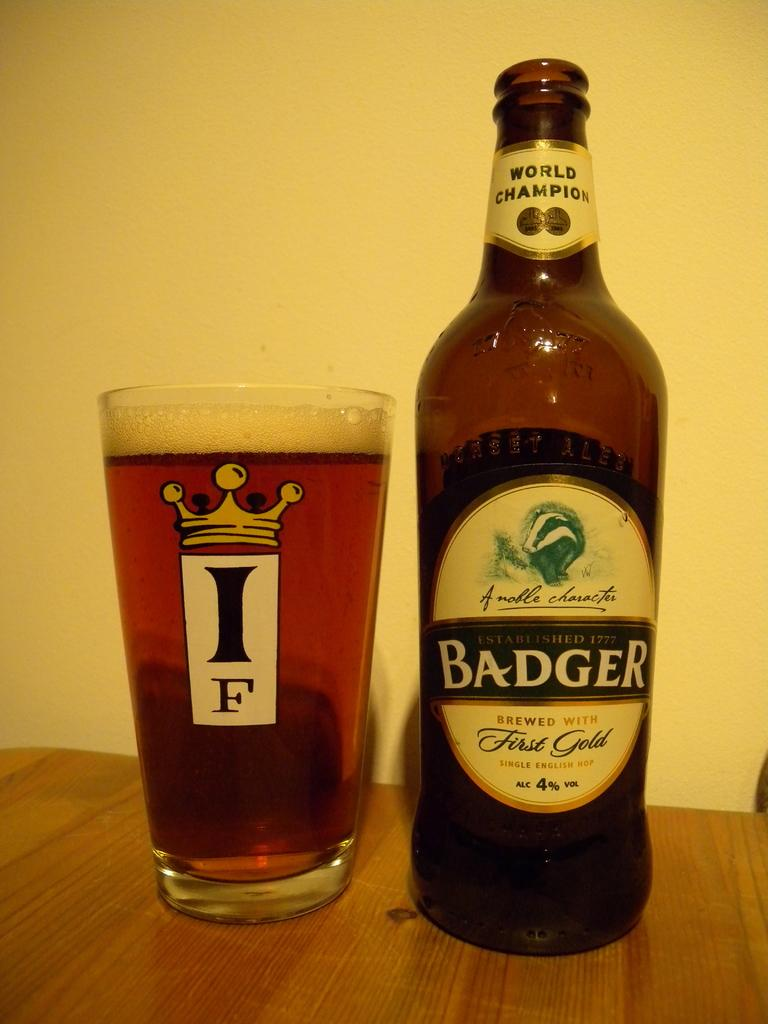<image>
Relay a brief, clear account of the picture shown. A bottle of Badger Beer has been poured into a glass on a table. 